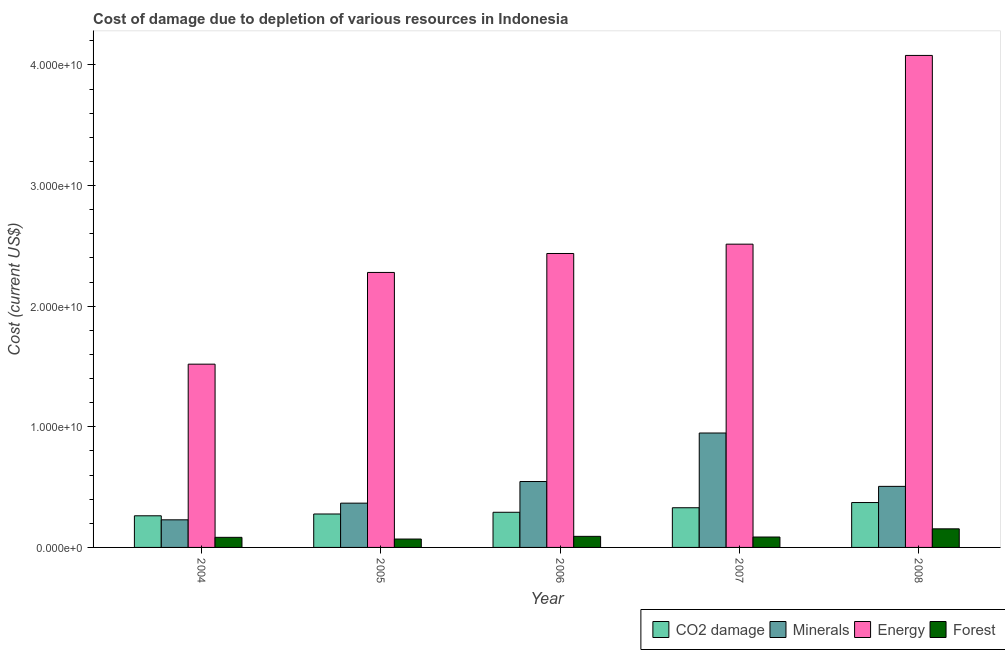How many groups of bars are there?
Give a very brief answer. 5. How many bars are there on the 3rd tick from the left?
Keep it short and to the point. 4. In how many cases, is the number of bars for a given year not equal to the number of legend labels?
Provide a short and direct response. 0. What is the cost of damage due to depletion of forests in 2008?
Provide a short and direct response. 1.54e+09. Across all years, what is the maximum cost of damage due to depletion of forests?
Provide a succinct answer. 1.54e+09. Across all years, what is the minimum cost of damage due to depletion of minerals?
Your response must be concise. 2.29e+09. In which year was the cost of damage due to depletion of energy maximum?
Provide a short and direct response. 2008. What is the total cost of damage due to depletion of minerals in the graph?
Provide a succinct answer. 2.60e+1. What is the difference between the cost of damage due to depletion of forests in 2004 and that in 2006?
Your answer should be compact. -8.19e+07. What is the difference between the cost of damage due to depletion of minerals in 2005 and the cost of damage due to depletion of coal in 2006?
Provide a short and direct response. -1.79e+09. What is the average cost of damage due to depletion of energy per year?
Make the answer very short. 2.57e+1. In the year 2008, what is the difference between the cost of damage due to depletion of minerals and cost of damage due to depletion of forests?
Make the answer very short. 0. What is the ratio of the cost of damage due to depletion of minerals in 2004 to that in 2006?
Provide a short and direct response. 0.42. Is the difference between the cost of damage due to depletion of minerals in 2005 and 2008 greater than the difference between the cost of damage due to depletion of forests in 2005 and 2008?
Your answer should be compact. No. What is the difference between the highest and the second highest cost of damage due to depletion of coal?
Your answer should be compact. 4.32e+08. What is the difference between the highest and the lowest cost of damage due to depletion of minerals?
Ensure brevity in your answer.  7.20e+09. Is it the case that in every year, the sum of the cost of damage due to depletion of energy and cost of damage due to depletion of forests is greater than the sum of cost of damage due to depletion of minerals and cost of damage due to depletion of coal?
Provide a succinct answer. Yes. What does the 2nd bar from the left in 2004 represents?
Offer a terse response. Minerals. What does the 3rd bar from the right in 2006 represents?
Provide a short and direct response. Minerals. How many bars are there?
Your answer should be very brief. 20. What is the difference between two consecutive major ticks on the Y-axis?
Your answer should be very brief. 1.00e+1. Does the graph contain grids?
Ensure brevity in your answer.  No. How many legend labels are there?
Your answer should be very brief. 4. How are the legend labels stacked?
Ensure brevity in your answer.  Horizontal. What is the title of the graph?
Keep it short and to the point. Cost of damage due to depletion of various resources in Indonesia . Does "Financial sector" appear as one of the legend labels in the graph?
Your response must be concise. No. What is the label or title of the X-axis?
Your answer should be compact. Year. What is the label or title of the Y-axis?
Provide a short and direct response. Cost (current US$). What is the Cost (current US$) of CO2 damage in 2004?
Offer a terse response. 2.62e+09. What is the Cost (current US$) in Minerals in 2004?
Your response must be concise. 2.29e+09. What is the Cost (current US$) in Energy in 2004?
Provide a succinct answer. 1.52e+1. What is the Cost (current US$) in Forest in 2004?
Ensure brevity in your answer.  8.36e+08. What is the Cost (current US$) in CO2 damage in 2005?
Your answer should be very brief. 2.77e+09. What is the Cost (current US$) of Minerals in 2005?
Offer a very short reply. 3.67e+09. What is the Cost (current US$) of Energy in 2005?
Your answer should be compact. 2.28e+1. What is the Cost (current US$) in Forest in 2005?
Offer a very short reply. 6.95e+08. What is the Cost (current US$) in CO2 damage in 2006?
Your answer should be very brief. 2.91e+09. What is the Cost (current US$) of Minerals in 2006?
Your answer should be very brief. 5.46e+09. What is the Cost (current US$) of Energy in 2006?
Your response must be concise. 2.44e+1. What is the Cost (current US$) of Forest in 2006?
Ensure brevity in your answer.  9.18e+08. What is the Cost (current US$) in CO2 damage in 2007?
Your answer should be very brief. 3.29e+09. What is the Cost (current US$) in Minerals in 2007?
Your answer should be compact. 9.48e+09. What is the Cost (current US$) in Energy in 2007?
Offer a very short reply. 2.51e+1. What is the Cost (current US$) in Forest in 2007?
Give a very brief answer. 8.62e+08. What is the Cost (current US$) in CO2 damage in 2008?
Offer a terse response. 3.72e+09. What is the Cost (current US$) in Minerals in 2008?
Your answer should be compact. 5.06e+09. What is the Cost (current US$) in Energy in 2008?
Offer a terse response. 4.08e+1. What is the Cost (current US$) in Forest in 2008?
Your answer should be very brief. 1.54e+09. Across all years, what is the maximum Cost (current US$) of CO2 damage?
Offer a very short reply. 3.72e+09. Across all years, what is the maximum Cost (current US$) in Minerals?
Ensure brevity in your answer.  9.48e+09. Across all years, what is the maximum Cost (current US$) in Energy?
Your answer should be very brief. 4.08e+1. Across all years, what is the maximum Cost (current US$) of Forest?
Give a very brief answer. 1.54e+09. Across all years, what is the minimum Cost (current US$) in CO2 damage?
Keep it short and to the point. 2.62e+09. Across all years, what is the minimum Cost (current US$) of Minerals?
Your answer should be very brief. 2.29e+09. Across all years, what is the minimum Cost (current US$) in Energy?
Your response must be concise. 1.52e+1. Across all years, what is the minimum Cost (current US$) of Forest?
Your answer should be compact. 6.95e+08. What is the total Cost (current US$) of CO2 damage in the graph?
Keep it short and to the point. 1.53e+1. What is the total Cost (current US$) in Minerals in the graph?
Ensure brevity in your answer.  2.60e+1. What is the total Cost (current US$) of Energy in the graph?
Offer a terse response. 1.28e+11. What is the total Cost (current US$) in Forest in the graph?
Provide a succinct answer. 4.85e+09. What is the difference between the Cost (current US$) of CO2 damage in 2004 and that in 2005?
Your answer should be very brief. -1.50e+08. What is the difference between the Cost (current US$) in Minerals in 2004 and that in 2005?
Offer a very short reply. -1.38e+09. What is the difference between the Cost (current US$) in Energy in 2004 and that in 2005?
Offer a terse response. -7.60e+09. What is the difference between the Cost (current US$) of Forest in 2004 and that in 2005?
Your response must be concise. 1.41e+08. What is the difference between the Cost (current US$) of CO2 damage in 2004 and that in 2006?
Provide a succinct answer. -2.91e+08. What is the difference between the Cost (current US$) in Minerals in 2004 and that in 2006?
Give a very brief answer. -3.17e+09. What is the difference between the Cost (current US$) in Energy in 2004 and that in 2006?
Offer a terse response. -9.17e+09. What is the difference between the Cost (current US$) in Forest in 2004 and that in 2006?
Your answer should be very brief. -8.19e+07. What is the difference between the Cost (current US$) in CO2 damage in 2004 and that in 2007?
Your answer should be very brief. -6.67e+08. What is the difference between the Cost (current US$) of Minerals in 2004 and that in 2007?
Provide a short and direct response. -7.20e+09. What is the difference between the Cost (current US$) in Energy in 2004 and that in 2007?
Keep it short and to the point. -9.95e+09. What is the difference between the Cost (current US$) of Forest in 2004 and that in 2007?
Your response must be concise. -2.62e+07. What is the difference between the Cost (current US$) in CO2 damage in 2004 and that in 2008?
Your answer should be compact. -1.10e+09. What is the difference between the Cost (current US$) of Minerals in 2004 and that in 2008?
Provide a short and direct response. -2.77e+09. What is the difference between the Cost (current US$) of Energy in 2004 and that in 2008?
Your response must be concise. -2.56e+1. What is the difference between the Cost (current US$) in Forest in 2004 and that in 2008?
Offer a terse response. -7.05e+08. What is the difference between the Cost (current US$) in CO2 damage in 2005 and that in 2006?
Your answer should be very brief. -1.42e+08. What is the difference between the Cost (current US$) of Minerals in 2005 and that in 2006?
Your answer should be compact. -1.79e+09. What is the difference between the Cost (current US$) in Energy in 2005 and that in 2006?
Give a very brief answer. -1.57e+09. What is the difference between the Cost (current US$) of Forest in 2005 and that in 2006?
Your answer should be very brief. -2.23e+08. What is the difference between the Cost (current US$) of CO2 damage in 2005 and that in 2007?
Provide a short and direct response. -5.17e+08. What is the difference between the Cost (current US$) in Minerals in 2005 and that in 2007?
Your answer should be compact. -5.81e+09. What is the difference between the Cost (current US$) in Energy in 2005 and that in 2007?
Offer a terse response. -2.34e+09. What is the difference between the Cost (current US$) of Forest in 2005 and that in 2007?
Ensure brevity in your answer.  -1.67e+08. What is the difference between the Cost (current US$) in CO2 damage in 2005 and that in 2008?
Keep it short and to the point. -9.49e+08. What is the difference between the Cost (current US$) in Minerals in 2005 and that in 2008?
Your answer should be very brief. -1.39e+09. What is the difference between the Cost (current US$) of Energy in 2005 and that in 2008?
Offer a terse response. -1.80e+1. What is the difference between the Cost (current US$) in Forest in 2005 and that in 2008?
Offer a terse response. -8.46e+08. What is the difference between the Cost (current US$) in CO2 damage in 2006 and that in 2007?
Offer a terse response. -3.75e+08. What is the difference between the Cost (current US$) of Minerals in 2006 and that in 2007?
Provide a short and direct response. -4.02e+09. What is the difference between the Cost (current US$) of Energy in 2006 and that in 2007?
Your answer should be compact. -7.73e+08. What is the difference between the Cost (current US$) in Forest in 2006 and that in 2007?
Give a very brief answer. 5.57e+07. What is the difference between the Cost (current US$) of CO2 damage in 2006 and that in 2008?
Ensure brevity in your answer.  -8.08e+08. What is the difference between the Cost (current US$) of Minerals in 2006 and that in 2008?
Your response must be concise. 4.01e+08. What is the difference between the Cost (current US$) of Energy in 2006 and that in 2008?
Your answer should be very brief. -1.64e+1. What is the difference between the Cost (current US$) in Forest in 2006 and that in 2008?
Provide a short and direct response. -6.24e+08. What is the difference between the Cost (current US$) in CO2 damage in 2007 and that in 2008?
Offer a terse response. -4.32e+08. What is the difference between the Cost (current US$) of Minerals in 2007 and that in 2008?
Your answer should be compact. 4.42e+09. What is the difference between the Cost (current US$) of Energy in 2007 and that in 2008?
Your answer should be compact. -1.56e+1. What is the difference between the Cost (current US$) in Forest in 2007 and that in 2008?
Give a very brief answer. -6.79e+08. What is the difference between the Cost (current US$) in CO2 damage in 2004 and the Cost (current US$) in Minerals in 2005?
Keep it short and to the point. -1.05e+09. What is the difference between the Cost (current US$) of CO2 damage in 2004 and the Cost (current US$) of Energy in 2005?
Keep it short and to the point. -2.02e+1. What is the difference between the Cost (current US$) in CO2 damage in 2004 and the Cost (current US$) in Forest in 2005?
Your response must be concise. 1.93e+09. What is the difference between the Cost (current US$) in Minerals in 2004 and the Cost (current US$) in Energy in 2005?
Your answer should be compact. -2.05e+1. What is the difference between the Cost (current US$) of Minerals in 2004 and the Cost (current US$) of Forest in 2005?
Offer a terse response. 1.59e+09. What is the difference between the Cost (current US$) in Energy in 2004 and the Cost (current US$) in Forest in 2005?
Ensure brevity in your answer.  1.45e+1. What is the difference between the Cost (current US$) in CO2 damage in 2004 and the Cost (current US$) in Minerals in 2006?
Provide a succinct answer. -2.84e+09. What is the difference between the Cost (current US$) of CO2 damage in 2004 and the Cost (current US$) of Energy in 2006?
Give a very brief answer. -2.17e+1. What is the difference between the Cost (current US$) in CO2 damage in 2004 and the Cost (current US$) in Forest in 2006?
Make the answer very short. 1.70e+09. What is the difference between the Cost (current US$) of Minerals in 2004 and the Cost (current US$) of Energy in 2006?
Give a very brief answer. -2.21e+1. What is the difference between the Cost (current US$) in Minerals in 2004 and the Cost (current US$) in Forest in 2006?
Give a very brief answer. 1.37e+09. What is the difference between the Cost (current US$) in Energy in 2004 and the Cost (current US$) in Forest in 2006?
Give a very brief answer. 1.43e+1. What is the difference between the Cost (current US$) in CO2 damage in 2004 and the Cost (current US$) in Minerals in 2007?
Provide a short and direct response. -6.86e+09. What is the difference between the Cost (current US$) of CO2 damage in 2004 and the Cost (current US$) of Energy in 2007?
Your answer should be very brief. -2.25e+1. What is the difference between the Cost (current US$) in CO2 damage in 2004 and the Cost (current US$) in Forest in 2007?
Your answer should be very brief. 1.76e+09. What is the difference between the Cost (current US$) in Minerals in 2004 and the Cost (current US$) in Energy in 2007?
Your response must be concise. -2.29e+1. What is the difference between the Cost (current US$) in Minerals in 2004 and the Cost (current US$) in Forest in 2007?
Offer a terse response. 1.43e+09. What is the difference between the Cost (current US$) of Energy in 2004 and the Cost (current US$) of Forest in 2007?
Keep it short and to the point. 1.43e+1. What is the difference between the Cost (current US$) of CO2 damage in 2004 and the Cost (current US$) of Minerals in 2008?
Keep it short and to the point. -2.44e+09. What is the difference between the Cost (current US$) of CO2 damage in 2004 and the Cost (current US$) of Energy in 2008?
Offer a very short reply. -3.82e+1. What is the difference between the Cost (current US$) in CO2 damage in 2004 and the Cost (current US$) in Forest in 2008?
Your answer should be very brief. 1.08e+09. What is the difference between the Cost (current US$) of Minerals in 2004 and the Cost (current US$) of Energy in 2008?
Ensure brevity in your answer.  -3.85e+1. What is the difference between the Cost (current US$) in Minerals in 2004 and the Cost (current US$) in Forest in 2008?
Ensure brevity in your answer.  7.47e+08. What is the difference between the Cost (current US$) in Energy in 2004 and the Cost (current US$) in Forest in 2008?
Make the answer very short. 1.36e+1. What is the difference between the Cost (current US$) in CO2 damage in 2005 and the Cost (current US$) in Minerals in 2006?
Your answer should be compact. -2.69e+09. What is the difference between the Cost (current US$) in CO2 damage in 2005 and the Cost (current US$) in Energy in 2006?
Your response must be concise. -2.16e+1. What is the difference between the Cost (current US$) in CO2 damage in 2005 and the Cost (current US$) in Forest in 2006?
Offer a terse response. 1.85e+09. What is the difference between the Cost (current US$) in Minerals in 2005 and the Cost (current US$) in Energy in 2006?
Provide a succinct answer. -2.07e+1. What is the difference between the Cost (current US$) in Minerals in 2005 and the Cost (current US$) in Forest in 2006?
Give a very brief answer. 2.75e+09. What is the difference between the Cost (current US$) of Energy in 2005 and the Cost (current US$) of Forest in 2006?
Your response must be concise. 2.19e+1. What is the difference between the Cost (current US$) in CO2 damage in 2005 and the Cost (current US$) in Minerals in 2007?
Give a very brief answer. -6.71e+09. What is the difference between the Cost (current US$) in CO2 damage in 2005 and the Cost (current US$) in Energy in 2007?
Your answer should be very brief. -2.24e+1. What is the difference between the Cost (current US$) of CO2 damage in 2005 and the Cost (current US$) of Forest in 2007?
Give a very brief answer. 1.91e+09. What is the difference between the Cost (current US$) of Minerals in 2005 and the Cost (current US$) of Energy in 2007?
Provide a succinct answer. -2.15e+1. What is the difference between the Cost (current US$) of Minerals in 2005 and the Cost (current US$) of Forest in 2007?
Offer a terse response. 2.81e+09. What is the difference between the Cost (current US$) in Energy in 2005 and the Cost (current US$) in Forest in 2007?
Offer a very short reply. 2.19e+1. What is the difference between the Cost (current US$) in CO2 damage in 2005 and the Cost (current US$) in Minerals in 2008?
Your answer should be compact. -2.29e+09. What is the difference between the Cost (current US$) in CO2 damage in 2005 and the Cost (current US$) in Energy in 2008?
Make the answer very short. -3.80e+1. What is the difference between the Cost (current US$) in CO2 damage in 2005 and the Cost (current US$) in Forest in 2008?
Offer a very short reply. 1.23e+09. What is the difference between the Cost (current US$) in Minerals in 2005 and the Cost (current US$) in Energy in 2008?
Offer a very short reply. -3.71e+1. What is the difference between the Cost (current US$) of Minerals in 2005 and the Cost (current US$) of Forest in 2008?
Provide a short and direct response. 2.13e+09. What is the difference between the Cost (current US$) of Energy in 2005 and the Cost (current US$) of Forest in 2008?
Provide a short and direct response. 2.13e+1. What is the difference between the Cost (current US$) in CO2 damage in 2006 and the Cost (current US$) in Minerals in 2007?
Offer a terse response. -6.57e+09. What is the difference between the Cost (current US$) of CO2 damage in 2006 and the Cost (current US$) of Energy in 2007?
Your response must be concise. -2.22e+1. What is the difference between the Cost (current US$) in CO2 damage in 2006 and the Cost (current US$) in Forest in 2007?
Your answer should be compact. 2.05e+09. What is the difference between the Cost (current US$) of Minerals in 2006 and the Cost (current US$) of Energy in 2007?
Provide a succinct answer. -1.97e+1. What is the difference between the Cost (current US$) in Minerals in 2006 and the Cost (current US$) in Forest in 2007?
Make the answer very short. 4.60e+09. What is the difference between the Cost (current US$) in Energy in 2006 and the Cost (current US$) in Forest in 2007?
Provide a short and direct response. 2.35e+1. What is the difference between the Cost (current US$) of CO2 damage in 2006 and the Cost (current US$) of Minerals in 2008?
Ensure brevity in your answer.  -2.15e+09. What is the difference between the Cost (current US$) of CO2 damage in 2006 and the Cost (current US$) of Energy in 2008?
Make the answer very short. -3.79e+1. What is the difference between the Cost (current US$) in CO2 damage in 2006 and the Cost (current US$) in Forest in 2008?
Keep it short and to the point. 1.37e+09. What is the difference between the Cost (current US$) of Minerals in 2006 and the Cost (current US$) of Energy in 2008?
Your answer should be compact. -3.53e+1. What is the difference between the Cost (current US$) of Minerals in 2006 and the Cost (current US$) of Forest in 2008?
Your response must be concise. 3.92e+09. What is the difference between the Cost (current US$) in Energy in 2006 and the Cost (current US$) in Forest in 2008?
Make the answer very short. 2.28e+1. What is the difference between the Cost (current US$) in CO2 damage in 2007 and the Cost (current US$) in Minerals in 2008?
Your response must be concise. -1.77e+09. What is the difference between the Cost (current US$) of CO2 damage in 2007 and the Cost (current US$) of Energy in 2008?
Keep it short and to the point. -3.75e+1. What is the difference between the Cost (current US$) of CO2 damage in 2007 and the Cost (current US$) of Forest in 2008?
Give a very brief answer. 1.75e+09. What is the difference between the Cost (current US$) in Minerals in 2007 and the Cost (current US$) in Energy in 2008?
Give a very brief answer. -3.13e+1. What is the difference between the Cost (current US$) in Minerals in 2007 and the Cost (current US$) in Forest in 2008?
Make the answer very short. 7.94e+09. What is the difference between the Cost (current US$) in Energy in 2007 and the Cost (current US$) in Forest in 2008?
Provide a succinct answer. 2.36e+1. What is the average Cost (current US$) of CO2 damage per year?
Your answer should be compact. 3.06e+09. What is the average Cost (current US$) of Minerals per year?
Ensure brevity in your answer.  5.19e+09. What is the average Cost (current US$) in Energy per year?
Your answer should be very brief. 2.57e+1. What is the average Cost (current US$) of Forest per year?
Offer a terse response. 9.71e+08. In the year 2004, what is the difference between the Cost (current US$) in CO2 damage and Cost (current US$) in Minerals?
Your answer should be compact. 3.34e+08. In the year 2004, what is the difference between the Cost (current US$) of CO2 damage and Cost (current US$) of Energy?
Make the answer very short. -1.26e+1. In the year 2004, what is the difference between the Cost (current US$) in CO2 damage and Cost (current US$) in Forest?
Give a very brief answer. 1.79e+09. In the year 2004, what is the difference between the Cost (current US$) of Minerals and Cost (current US$) of Energy?
Provide a succinct answer. -1.29e+1. In the year 2004, what is the difference between the Cost (current US$) of Minerals and Cost (current US$) of Forest?
Your answer should be compact. 1.45e+09. In the year 2004, what is the difference between the Cost (current US$) of Energy and Cost (current US$) of Forest?
Give a very brief answer. 1.44e+1. In the year 2005, what is the difference between the Cost (current US$) of CO2 damage and Cost (current US$) of Minerals?
Provide a succinct answer. -8.98e+08. In the year 2005, what is the difference between the Cost (current US$) in CO2 damage and Cost (current US$) in Energy?
Make the answer very short. -2.00e+1. In the year 2005, what is the difference between the Cost (current US$) in CO2 damage and Cost (current US$) in Forest?
Your answer should be very brief. 2.08e+09. In the year 2005, what is the difference between the Cost (current US$) of Minerals and Cost (current US$) of Energy?
Ensure brevity in your answer.  -1.91e+1. In the year 2005, what is the difference between the Cost (current US$) in Minerals and Cost (current US$) in Forest?
Make the answer very short. 2.98e+09. In the year 2005, what is the difference between the Cost (current US$) in Energy and Cost (current US$) in Forest?
Keep it short and to the point. 2.21e+1. In the year 2006, what is the difference between the Cost (current US$) of CO2 damage and Cost (current US$) of Minerals?
Provide a succinct answer. -2.55e+09. In the year 2006, what is the difference between the Cost (current US$) in CO2 damage and Cost (current US$) in Energy?
Keep it short and to the point. -2.15e+1. In the year 2006, what is the difference between the Cost (current US$) of CO2 damage and Cost (current US$) of Forest?
Your response must be concise. 2.00e+09. In the year 2006, what is the difference between the Cost (current US$) of Minerals and Cost (current US$) of Energy?
Your answer should be compact. -1.89e+1. In the year 2006, what is the difference between the Cost (current US$) of Minerals and Cost (current US$) of Forest?
Your answer should be compact. 4.54e+09. In the year 2006, what is the difference between the Cost (current US$) of Energy and Cost (current US$) of Forest?
Your response must be concise. 2.34e+1. In the year 2007, what is the difference between the Cost (current US$) in CO2 damage and Cost (current US$) in Minerals?
Give a very brief answer. -6.20e+09. In the year 2007, what is the difference between the Cost (current US$) in CO2 damage and Cost (current US$) in Energy?
Provide a succinct answer. -2.18e+1. In the year 2007, what is the difference between the Cost (current US$) of CO2 damage and Cost (current US$) of Forest?
Your answer should be very brief. 2.43e+09. In the year 2007, what is the difference between the Cost (current US$) of Minerals and Cost (current US$) of Energy?
Provide a short and direct response. -1.57e+1. In the year 2007, what is the difference between the Cost (current US$) of Minerals and Cost (current US$) of Forest?
Your response must be concise. 8.62e+09. In the year 2007, what is the difference between the Cost (current US$) in Energy and Cost (current US$) in Forest?
Your answer should be very brief. 2.43e+1. In the year 2008, what is the difference between the Cost (current US$) of CO2 damage and Cost (current US$) of Minerals?
Make the answer very short. -1.34e+09. In the year 2008, what is the difference between the Cost (current US$) in CO2 damage and Cost (current US$) in Energy?
Offer a very short reply. -3.71e+1. In the year 2008, what is the difference between the Cost (current US$) in CO2 damage and Cost (current US$) in Forest?
Make the answer very short. 2.18e+09. In the year 2008, what is the difference between the Cost (current US$) in Minerals and Cost (current US$) in Energy?
Your response must be concise. -3.57e+1. In the year 2008, what is the difference between the Cost (current US$) in Minerals and Cost (current US$) in Forest?
Your answer should be compact. 3.52e+09. In the year 2008, what is the difference between the Cost (current US$) of Energy and Cost (current US$) of Forest?
Offer a very short reply. 3.92e+1. What is the ratio of the Cost (current US$) of CO2 damage in 2004 to that in 2005?
Provide a succinct answer. 0.95. What is the ratio of the Cost (current US$) of Minerals in 2004 to that in 2005?
Provide a short and direct response. 0.62. What is the ratio of the Cost (current US$) of Energy in 2004 to that in 2005?
Offer a terse response. 0.67. What is the ratio of the Cost (current US$) in Forest in 2004 to that in 2005?
Offer a terse response. 1.2. What is the ratio of the Cost (current US$) in Minerals in 2004 to that in 2006?
Make the answer very short. 0.42. What is the ratio of the Cost (current US$) of Energy in 2004 to that in 2006?
Provide a short and direct response. 0.62. What is the ratio of the Cost (current US$) in Forest in 2004 to that in 2006?
Offer a very short reply. 0.91. What is the ratio of the Cost (current US$) of CO2 damage in 2004 to that in 2007?
Make the answer very short. 0.8. What is the ratio of the Cost (current US$) in Minerals in 2004 to that in 2007?
Provide a succinct answer. 0.24. What is the ratio of the Cost (current US$) in Energy in 2004 to that in 2007?
Provide a succinct answer. 0.6. What is the ratio of the Cost (current US$) of Forest in 2004 to that in 2007?
Give a very brief answer. 0.97. What is the ratio of the Cost (current US$) in CO2 damage in 2004 to that in 2008?
Make the answer very short. 0.7. What is the ratio of the Cost (current US$) in Minerals in 2004 to that in 2008?
Ensure brevity in your answer.  0.45. What is the ratio of the Cost (current US$) in Energy in 2004 to that in 2008?
Provide a succinct answer. 0.37. What is the ratio of the Cost (current US$) of Forest in 2004 to that in 2008?
Provide a succinct answer. 0.54. What is the ratio of the Cost (current US$) in CO2 damage in 2005 to that in 2006?
Provide a short and direct response. 0.95. What is the ratio of the Cost (current US$) of Minerals in 2005 to that in 2006?
Your response must be concise. 0.67. What is the ratio of the Cost (current US$) in Energy in 2005 to that in 2006?
Your answer should be compact. 0.94. What is the ratio of the Cost (current US$) in Forest in 2005 to that in 2006?
Your response must be concise. 0.76. What is the ratio of the Cost (current US$) of CO2 damage in 2005 to that in 2007?
Keep it short and to the point. 0.84. What is the ratio of the Cost (current US$) of Minerals in 2005 to that in 2007?
Offer a very short reply. 0.39. What is the ratio of the Cost (current US$) of Energy in 2005 to that in 2007?
Give a very brief answer. 0.91. What is the ratio of the Cost (current US$) in Forest in 2005 to that in 2007?
Provide a short and direct response. 0.81. What is the ratio of the Cost (current US$) in CO2 damage in 2005 to that in 2008?
Your answer should be compact. 0.74. What is the ratio of the Cost (current US$) of Minerals in 2005 to that in 2008?
Your response must be concise. 0.73. What is the ratio of the Cost (current US$) of Energy in 2005 to that in 2008?
Your answer should be very brief. 0.56. What is the ratio of the Cost (current US$) of Forest in 2005 to that in 2008?
Your answer should be compact. 0.45. What is the ratio of the Cost (current US$) in CO2 damage in 2006 to that in 2007?
Provide a short and direct response. 0.89. What is the ratio of the Cost (current US$) in Minerals in 2006 to that in 2007?
Keep it short and to the point. 0.58. What is the ratio of the Cost (current US$) of Energy in 2006 to that in 2007?
Ensure brevity in your answer.  0.97. What is the ratio of the Cost (current US$) in Forest in 2006 to that in 2007?
Ensure brevity in your answer.  1.06. What is the ratio of the Cost (current US$) of CO2 damage in 2006 to that in 2008?
Provide a short and direct response. 0.78. What is the ratio of the Cost (current US$) of Minerals in 2006 to that in 2008?
Give a very brief answer. 1.08. What is the ratio of the Cost (current US$) in Energy in 2006 to that in 2008?
Offer a very short reply. 0.6. What is the ratio of the Cost (current US$) of Forest in 2006 to that in 2008?
Ensure brevity in your answer.  0.6. What is the ratio of the Cost (current US$) of CO2 damage in 2007 to that in 2008?
Provide a short and direct response. 0.88. What is the ratio of the Cost (current US$) of Minerals in 2007 to that in 2008?
Offer a very short reply. 1.87. What is the ratio of the Cost (current US$) of Energy in 2007 to that in 2008?
Give a very brief answer. 0.62. What is the ratio of the Cost (current US$) in Forest in 2007 to that in 2008?
Provide a succinct answer. 0.56. What is the difference between the highest and the second highest Cost (current US$) in CO2 damage?
Provide a succinct answer. 4.32e+08. What is the difference between the highest and the second highest Cost (current US$) in Minerals?
Your answer should be very brief. 4.02e+09. What is the difference between the highest and the second highest Cost (current US$) in Energy?
Make the answer very short. 1.56e+1. What is the difference between the highest and the second highest Cost (current US$) of Forest?
Provide a short and direct response. 6.24e+08. What is the difference between the highest and the lowest Cost (current US$) in CO2 damage?
Make the answer very short. 1.10e+09. What is the difference between the highest and the lowest Cost (current US$) of Minerals?
Give a very brief answer. 7.20e+09. What is the difference between the highest and the lowest Cost (current US$) in Energy?
Give a very brief answer. 2.56e+1. What is the difference between the highest and the lowest Cost (current US$) in Forest?
Provide a succinct answer. 8.46e+08. 